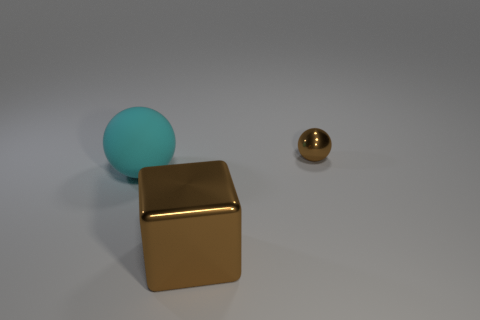Subtract all balls. How many objects are left? 1 Add 3 green metal spheres. How many objects exist? 6 Subtract all cyan balls. How many balls are left? 1 Subtract 1 cubes. How many cubes are left? 0 Subtract all blue balls. Subtract all red blocks. How many balls are left? 2 Subtract all purple cubes. How many gray balls are left? 0 Subtract all green cylinders. Subtract all shiny objects. How many objects are left? 1 Add 2 metal balls. How many metal balls are left? 3 Add 1 yellow rubber blocks. How many yellow rubber blocks exist? 1 Subtract 1 brown blocks. How many objects are left? 2 